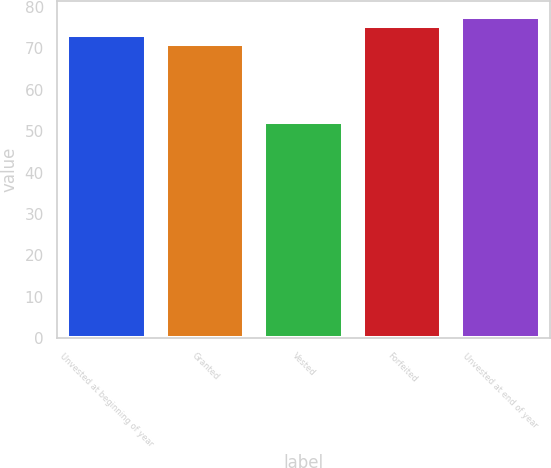Convert chart to OTSL. <chart><loc_0><loc_0><loc_500><loc_500><bar_chart><fcel>Unvested at beginning of year<fcel>Granted<fcel>Vested<fcel>Forfeited<fcel>Unvested at end of year<nl><fcel>73.23<fcel>71.09<fcel>52.26<fcel>75.37<fcel>77.51<nl></chart> 